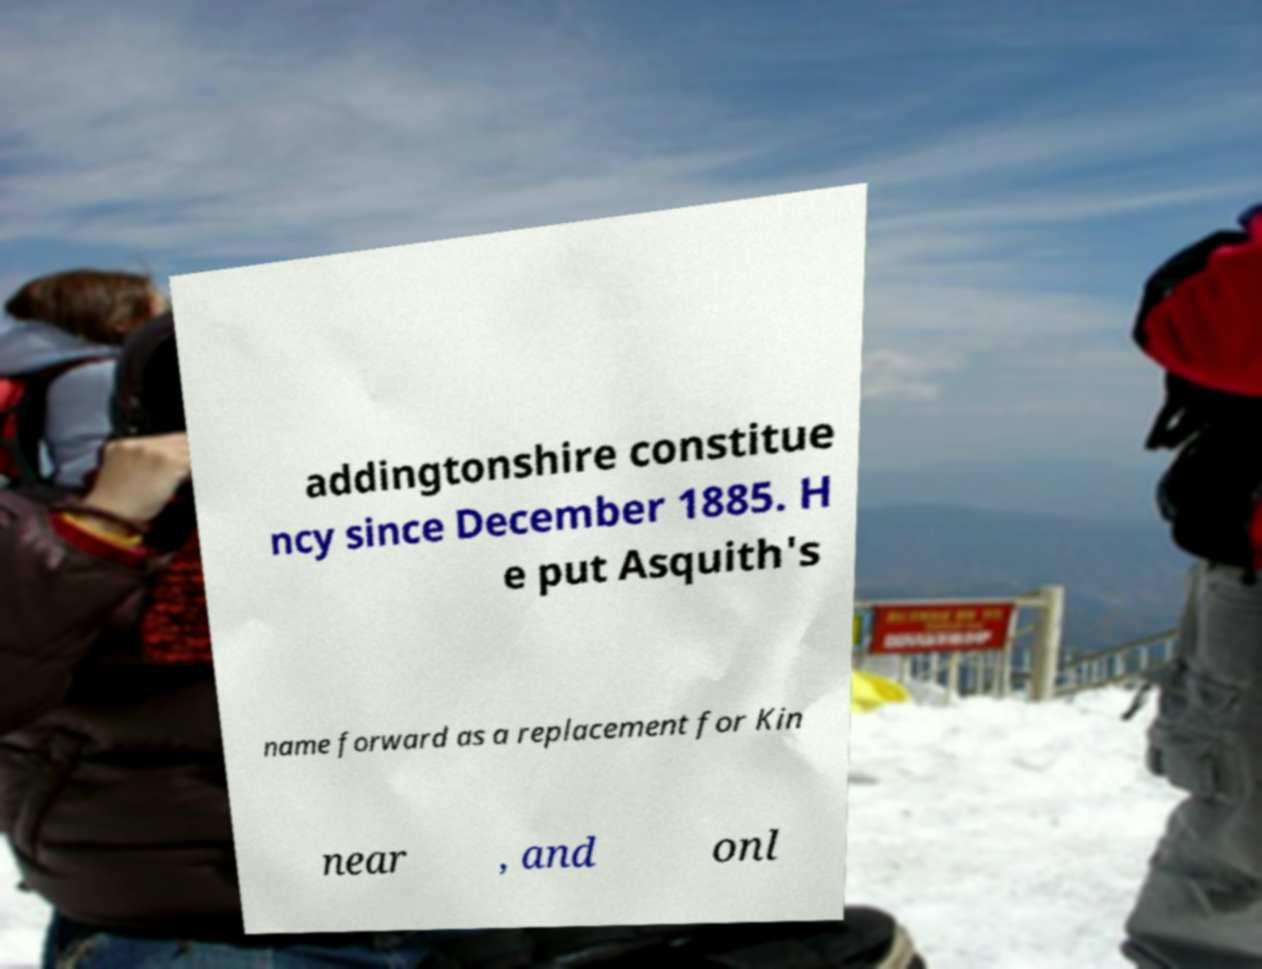Could you assist in decoding the text presented in this image and type it out clearly? addingtonshire constitue ncy since December 1885. H e put Asquith's name forward as a replacement for Kin near , and onl 